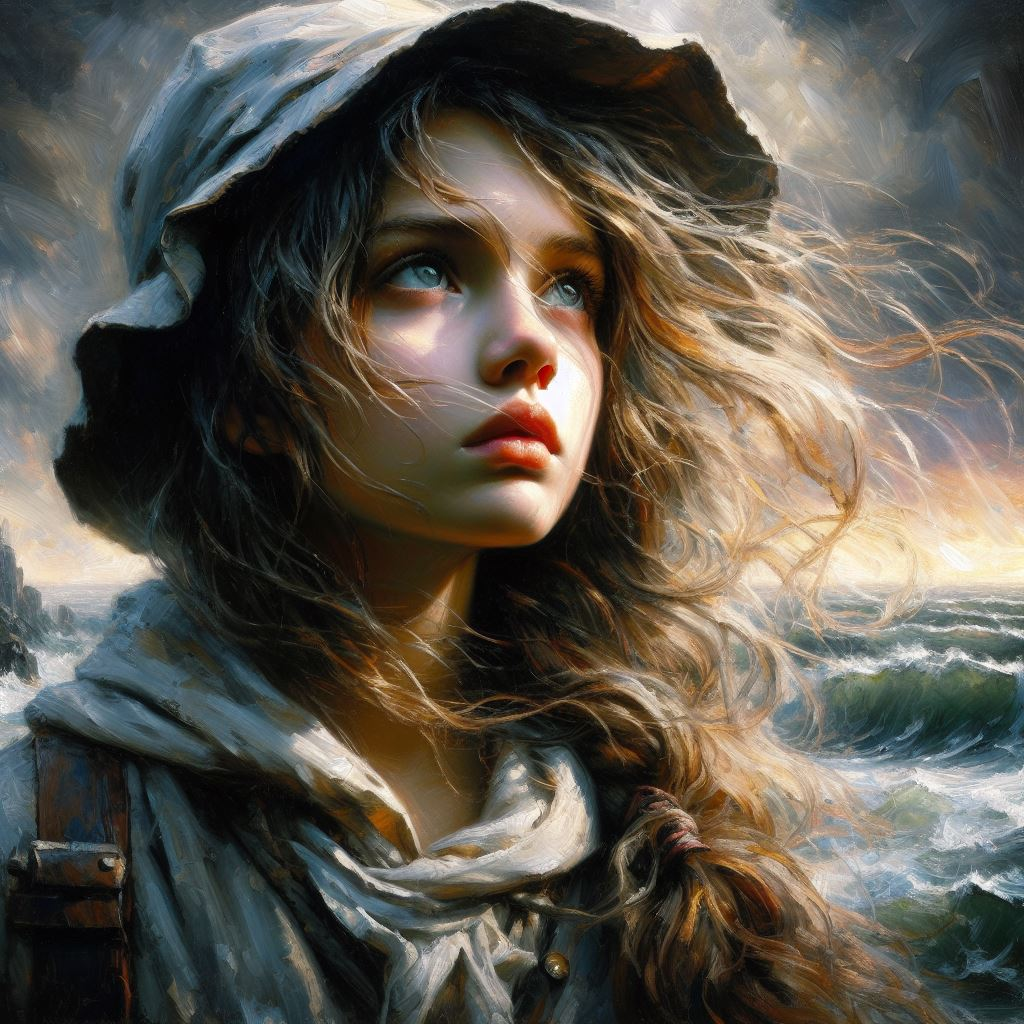Write a creative Instagram caption  "Embracing the storm within, her eyes mirrored the tumultuous sea of dreams and determination. 🌊✨ #SoulfulSiren #DreamsAsDeepAsTheOcean" 